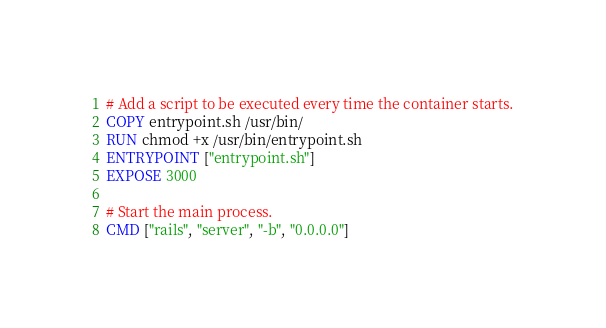<code> <loc_0><loc_0><loc_500><loc_500><_Dockerfile_># Add a script to be executed every time the container starts.
COPY entrypoint.sh /usr/bin/
RUN chmod +x /usr/bin/entrypoint.sh
ENTRYPOINT ["entrypoint.sh"]
EXPOSE 3000

# Start the main process.
CMD ["rails", "server", "-b", "0.0.0.0"]</code> 